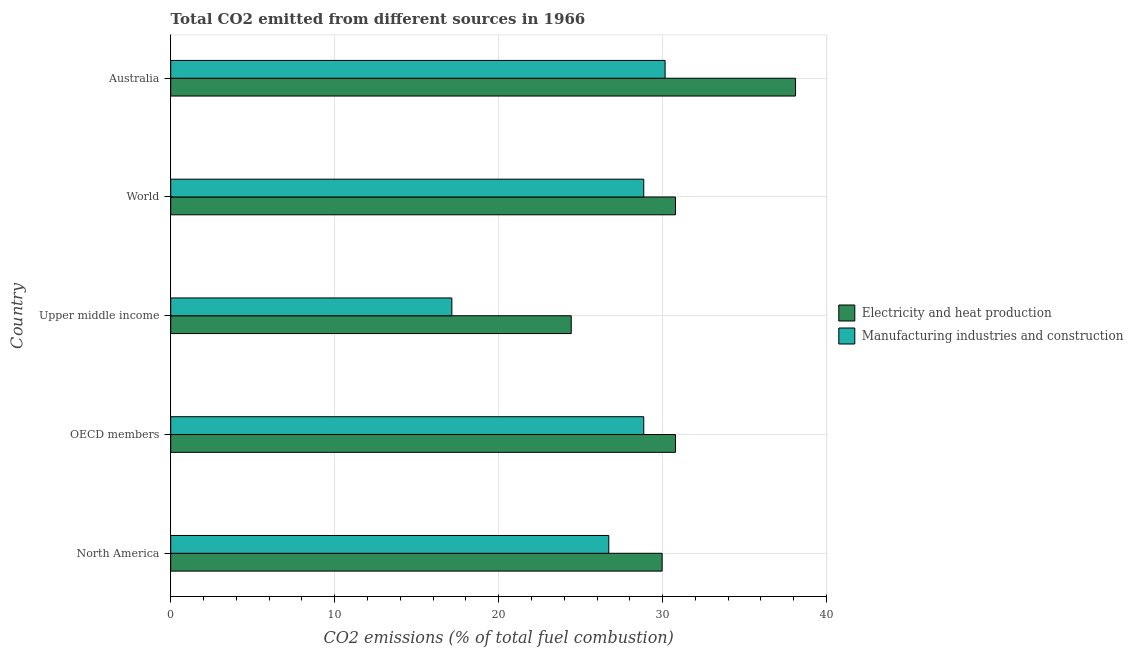How many groups of bars are there?
Your answer should be very brief. 5. Are the number of bars per tick equal to the number of legend labels?
Ensure brevity in your answer.  Yes. How many bars are there on the 1st tick from the bottom?
Ensure brevity in your answer.  2. What is the label of the 2nd group of bars from the top?
Your answer should be compact. World. What is the co2 emissions due to manufacturing industries in OECD members?
Offer a terse response. 28.85. Across all countries, what is the maximum co2 emissions due to electricity and heat production?
Your answer should be very brief. 38.11. Across all countries, what is the minimum co2 emissions due to electricity and heat production?
Your response must be concise. 24.43. In which country was the co2 emissions due to electricity and heat production minimum?
Your response must be concise. Upper middle income. What is the total co2 emissions due to manufacturing industries in the graph?
Give a very brief answer. 131.72. What is the difference between the co2 emissions due to manufacturing industries in OECD members and that in Upper middle income?
Your answer should be compact. 11.7. What is the difference between the co2 emissions due to manufacturing industries in World and the co2 emissions due to electricity and heat production in Australia?
Keep it short and to the point. -9.26. What is the average co2 emissions due to electricity and heat production per country?
Ensure brevity in your answer.  30.82. What is the difference between the co2 emissions due to electricity and heat production and co2 emissions due to manufacturing industries in North America?
Offer a very short reply. 3.25. In how many countries, is the co2 emissions due to electricity and heat production greater than 30 %?
Make the answer very short. 3. What is the ratio of the co2 emissions due to electricity and heat production in Upper middle income to that in World?
Ensure brevity in your answer.  0.79. Is the co2 emissions due to electricity and heat production in North America less than that in Upper middle income?
Provide a succinct answer. No. Is the difference between the co2 emissions due to electricity and heat production in Australia and North America greater than the difference between the co2 emissions due to manufacturing industries in Australia and North America?
Provide a short and direct response. Yes. What is the difference between the highest and the second highest co2 emissions due to electricity and heat production?
Provide a succinct answer. 7.32. What is the difference between the highest and the lowest co2 emissions due to electricity and heat production?
Keep it short and to the point. 13.68. In how many countries, is the co2 emissions due to manufacturing industries greater than the average co2 emissions due to manufacturing industries taken over all countries?
Keep it short and to the point. 4. What does the 1st bar from the top in Upper middle income represents?
Keep it short and to the point. Manufacturing industries and construction. What does the 2nd bar from the bottom in OECD members represents?
Your answer should be compact. Manufacturing industries and construction. How many bars are there?
Your answer should be compact. 10. What is the difference between two consecutive major ticks on the X-axis?
Give a very brief answer. 10. Does the graph contain any zero values?
Provide a short and direct response. No. Does the graph contain grids?
Your answer should be very brief. Yes. How many legend labels are there?
Ensure brevity in your answer.  2. What is the title of the graph?
Your answer should be compact. Total CO2 emitted from different sources in 1966. What is the label or title of the X-axis?
Provide a short and direct response. CO2 emissions (% of total fuel combustion). What is the label or title of the Y-axis?
Give a very brief answer. Country. What is the CO2 emissions (% of total fuel combustion) of Electricity and heat production in North America?
Offer a very short reply. 29.97. What is the CO2 emissions (% of total fuel combustion) of Manufacturing industries and construction in North America?
Your answer should be very brief. 26.72. What is the CO2 emissions (% of total fuel combustion) of Electricity and heat production in OECD members?
Offer a very short reply. 30.79. What is the CO2 emissions (% of total fuel combustion) in Manufacturing industries and construction in OECD members?
Your response must be concise. 28.85. What is the CO2 emissions (% of total fuel combustion) of Electricity and heat production in Upper middle income?
Make the answer very short. 24.43. What is the CO2 emissions (% of total fuel combustion) of Manufacturing industries and construction in Upper middle income?
Provide a succinct answer. 17.15. What is the CO2 emissions (% of total fuel combustion) of Electricity and heat production in World?
Ensure brevity in your answer.  30.79. What is the CO2 emissions (% of total fuel combustion) in Manufacturing industries and construction in World?
Your response must be concise. 28.85. What is the CO2 emissions (% of total fuel combustion) of Electricity and heat production in Australia?
Your answer should be very brief. 38.11. What is the CO2 emissions (% of total fuel combustion) of Manufacturing industries and construction in Australia?
Provide a short and direct response. 30.15. Across all countries, what is the maximum CO2 emissions (% of total fuel combustion) of Electricity and heat production?
Your response must be concise. 38.11. Across all countries, what is the maximum CO2 emissions (% of total fuel combustion) in Manufacturing industries and construction?
Offer a terse response. 30.15. Across all countries, what is the minimum CO2 emissions (% of total fuel combustion) of Electricity and heat production?
Ensure brevity in your answer.  24.43. Across all countries, what is the minimum CO2 emissions (% of total fuel combustion) in Manufacturing industries and construction?
Keep it short and to the point. 17.15. What is the total CO2 emissions (% of total fuel combustion) in Electricity and heat production in the graph?
Provide a succinct answer. 154.08. What is the total CO2 emissions (% of total fuel combustion) of Manufacturing industries and construction in the graph?
Your answer should be compact. 131.72. What is the difference between the CO2 emissions (% of total fuel combustion) of Electricity and heat production in North America and that in OECD members?
Your response must be concise. -0.82. What is the difference between the CO2 emissions (% of total fuel combustion) of Manufacturing industries and construction in North America and that in OECD members?
Provide a succinct answer. -2.13. What is the difference between the CO2 emissions (% of total fuel combustion) of Electricity and heat production in North America and that in Upper middle income?
Make the answer very short. 5.54. What is the difference between the CO2 emissions (% of total fuel combustion) of Manufacturing industries and construction in North America and that in Upper middle income?
Offer a terse response. 9.57. What is the difference between the CO2 emissions (% of total fuel combustion) of Electricity and heat production in North America and that in World?
Keep it short and to the point. -0.82. What is the difference between the CO2 emissions (% of total fuel combustion) in Manufacturing industries and construction in North America and that in World?
Keep it short and to the point. -2.13. What is the difference between the CO2 emissions (% of total fuel combustion) in Electricity and heat production in North America and that in Australia?
Keep it short and to the point. -8.14. What is the difference between the CO2 emissions (% of total fuel combustion) of Manufacturing industries and construction in North America and that in Australia?
Provide a succinct answer. -3.43. What is the difference between the CO2 emissions (% of total fuel combustion) in Electricity and heat production in OECD members and that in Upper middle income?
Your answer should be very brief. 6.36. What is the difference between the CO2 emissions (% of total fuel combustion) of Manufacturing industries and construction in OECD members and that in Upper middle income?
Ensure brevity in your answer.  11.7. What is the difference between the CO2 emissions (% of total fuel combustion) in Electricity and heat production in OECD members and that in World?
Keep it short and to the point. 0. What is the difference between the CO2 emissions (% of total fuel combustion) of Manufacturing industries and construction in OECD members and that in World?
Your response must be concise. 0. What is the difference between the CO2 emissions (% of total fuel combustion) in Electricity and heat production in OECD members and that in Australia?
Provide a succinct answer. -7.32. What is the difference between the CO2 emissions (% of total fuel combustion) of Manufacturing industries and construction in OECD members and that in Australia?
Keep it short and to the point. -1.3. What is the difference between the CO2 emissions (% of total fuel combustion) in Electricity and heat production in Upper middle income and that in World?
Provide a succinct answer. -6.36. What is the difference between the CO2 emissions (% of total fuel combustion) in Manufacturing industries and construction in Upper middle income and that in World?
Your answer should be compact. -11.7. What is the difference between the CO2 emissions (% of total fuel combustion) in Electricity and heat production in Upper middle income and that in Australia?
Your response must be concise. -13.68. What is the difference between the CO2 emissions (% of total fuel combustion) in Manufacturing industries and construction in Upper middle income and that in Australia?
Provide a succinct answer. -13. What is the difference between the CO2 emissions (% of total fuel combustion) of Electricity and heat production in World and that in Australia?
Make the answer very short. -7.32. What is the difference between the CO2 emissions (% of total fuel combustion) of Manufacturing industries and construction in World and that in Australia?
Your response must be concise. -1.3. What is the difference between the CO2 emissions (% of total fuel combustion) of Electricity and heat production in North America and the CO2 emissions (% of total fuel combustion) of Manufacturing industries and construction in OECD members?
Provide a short and direct response. 1.12. What is the difference between the CO2 emissions (% of total fuel combustion) in Electricity and heat production in North America and the CO2 emissions (% of total fuel combustion) in Manufacturing industries and construction in Upper middle income?
Your response must be concise. 12.82. What is the difference between the CO2 emissions (% of total fuel combustion) of Electricity and heat production in North America and the CO2 emissions (% of total fuel combustion) of Manufacturing industries and construction in World?
Your response must be concise. 1.12. What is the difference between the CO2 emissions (% of total fuel combustion) of Electricity and heat production in North America and the CO2 emissions (% of total fuel combustion) of Manufacturing industries and construction in Australia?
Make the answer very short. -0.18. What is the difference between the CO2 emissions (% of total fuel combustion) of Electricity and heat production in OECD members and the CO2 emissions (% of total fuel combustion) of Manufacturing industries and construction in Upper middle income?
Provide a short and direct response. 13.64. What is the difference between the CO2 emissions (% of total fuel combustion) in Electricity and heat production in OECD members and the CO2 emissions (% of total fuel combustion) in Manufacturing industries and construction in World?
Offer a terse response. 1.94. What is the difference between the CO2 emissions (% of total fuel combustion) of Electricity and heat production in OECD members and the CO2 emissions (% of total fuel combustion) of Manufacturing industries and construction in Australia?
Offer a very short reply. 0.63. What is the difference between the CO2 emissions (% of total fuel combustion) of Electricity and heat production in Upper middle income and the CO2 emissions (% of total fuel combustion) of Manufacturing industries and construction in World?
Your answer should be compact. -4.42. What is the difference between the CO2 emissions (% of total fuel combustion) of Electricity and heat production in Upper middle income and the CO2 emissions (% of total fuel combustion) of Manufacturing industries and construction in Australia?
Ensure brevity in your answer.  -5.72. What is the difference between the CO2 emissions (% of total fuel combustion) of Electricity and heat production in World and the CO2 emissions (% of total fuel combustion) of Manufacturing industries and construction in Australia?
Your answer should be very brief. 0.63. What is the average CO2 emissions (% of total fuel combustion) of Electricity and heat production per country?
Provide a short and direct response. 30.82. What is the average CO2 emissions (% of total fuel combustion) of Manufacturing industries and construction per country?
Your response must be concise. 26.34. What is the difference between the CO2 emissions (% of total fuel combustion) in Electricity and heat production and CO2 emissions (% of total fuel combustion) in Manufacturing industries and construction in North America?
Make the answer very short. 3.25. What is the difference between the CO2 emissions (% of total fuel combustion) of Electricity and heat production and CO2 emissions (% of total fuel combustion) of Manufacturing industries and construction in OECD members?
Your response must be concise. 1.94. What is the difference between the CO2 emissions (% of total fuel combustion) of Electricity and heat production and CO2 emissions (% of total fuel combustion) of Manufacturing industries and construction in Upper middle income?
Provide a succinct answer. 7.28. What is the difference between the CO2 emissions (% of total fuel combustion) of Electricity and heat production and CO2 emissions (% of total fuel combustion) of Manufacturing industries and construction in World?
Provide a short and direct response. 1.94. What is the difference between the CO2 emissions (% of total fuel combustion) in Electricity and heat production and CO2 emissions (% of total fuel combustion) in Manufacturing industries and construction in Australia?
Give a very brief answer. 7.96. What is the ratio of the CO2 emissions (% of total fuel combustion) of Electricity and heat production in North America to that in OECD members?
Provide a succinct answer. 0.97. What is the ratio of the CO2 emissions (% of total fuel combustion) in Manufacturing industries and construction in North America to that in OECD members?
Provide a succinct answer. 0.93. What is the ratio of the CO2 emissions (% of total fuel combustion) in Electricity and heat production in North America to that in Upper middle income?
Provide a short and direct response. 1.23. What is the ratio of the CO2 emissions (% of total fuel combustion) of Manufacturing industries and construction in North America to that in Upper middle income?
Provide a short and direct response. 1.56. What is the ratio of the CO2 emissions (% of total fuel combustion) of Electricity and heat production in North America to that in World?
Offer a terse response. 0.97. What is the ratio of the CO2 emissions (% of total fuel combustion) in Manufacturing industries and construction in North America to that in World?
Provide a short and direct response. 0.93. What is the ratio of the CO2 emissions (% of total fuel combustion) of Electricity and heat production in North America to that in Australia?
Give a very brief answer. 0.79. What is the ratio of the CO2 emissions (% of total fuel combustion) of Manufacturing industries and construction in North America to that in Australia?
Keep it short and to the point. 0.89. What is the ratio of the CO2 emissions (% of total fuel combustion) of Electricity and heat production in OECD members to that in Upper middle income?
Offer a terse response. 1.26. What is the ratio of the CO2 emissions (% of total fuel combustion) of Manufacturing industries and construction in OECD members to that in Upper middle income?
Your answer should be compact. 1.68. What is the ratio of the CO2 emissions (% of total fuel combustion) of Electricity and heat production in OECD members to that in World?
Your answer should be very brief. 1. What is the ratio of the CO2 emissions (% of total fuel combustion) in Electricity and heat production in OECD members to that in Australia?
Provide a succinct answer. 0.81. What is the ratio of the CO2 emissions (% of total fuel combustion) in Manufacturing industries and construction in OECD members to that in Australia?
Provide a succinct answer. 0.96. What is the ratio of the CO2 emissions (% of total fuel combustion) in Electricity and heat production in Upper middle income to that in World?
Offer a very short reply. 0.79. What is the ratio of the CO2 emissions (% of total fuel combustion) in Manufacturing industries and construction in Upper middle income to that in World?
Your answer should be very brief. 0.59. What is the ratio of the CO2 emissions (% of total fuel combustion) of Electricity and heat production in Upper middle income to that in Australia?
Your answer should be very brief. 0.64. What is the ratio of the CO2 emissions (% of total fuel combustion) in Manufacturing industries and construction in Upper middle income to that in Australia?
Ensure brevity in your answer.  0.57. What is the ratio of the CO2 emissions (% of total fuel combustion) in Electricity and heat production in World to that in Australia?
Offer a terse response. 0.81. What is the ratio of the CO2 emissions (% of total fuel combustion) in Manufacturing industries and construction in World to that in Australia?
Keep it short and to the point. 0.96. What is the difference between the highest and the second highest CO2 emissions (% of total fuel combustion) in Electricity and heat production?
Your answer should be compact. 7.32. What is the difference between the highest and the second highest CO2 emissions (% of total fuel combustion) of Manufacturing industries and construction?
Your answer should be very brief. 1.3. What is the difference between the highest and the lowest CO2 emissions (% of total fuel combustion) in Electricity and heat production?
Keep it short and to the point. 13.68. What is the difference between the highest and the lowest CO2 emissions (% of total fuel combustion) in Manufacturing industries and construction?
Ensure brevity in your answer.  13. 